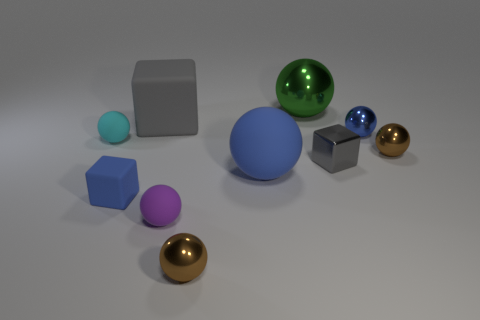There is another block that is the same color as the big block; what is its material?
Ensure brevity in your answer.  Metal. What number of things are shiny blocks or brown spheres?
Make the answer very short. 3. How many other things are the same color as the shiny cube?
Make the answer very short. 1. What shape is the gray metal thing that is the same size as the purple object?
Your answer should be very brief. Cube. There is a matte cube that is in front of the gray matte object; what color is it?
Your answer should be very brief. Blue. What number of things are large matte balls in front of the big metallic sphere or small shiny things that are in front of the small gray shiny cube?
Your response must be concise. 2. Do the green sphere and the gray matte object have the same size?
Your answer should be very brief. Yes. How many spheres are matte objects or purple matte objects?
Provide a short and direct response. 3. What number of things are behind the metallic block and on the right side of the big metallic thing?
Ensure brevity in your answer.  2. There is a green object; does it have the same size as the brown thing that is to the right of the large metallic thing?
Provide a short and direct response. No. 